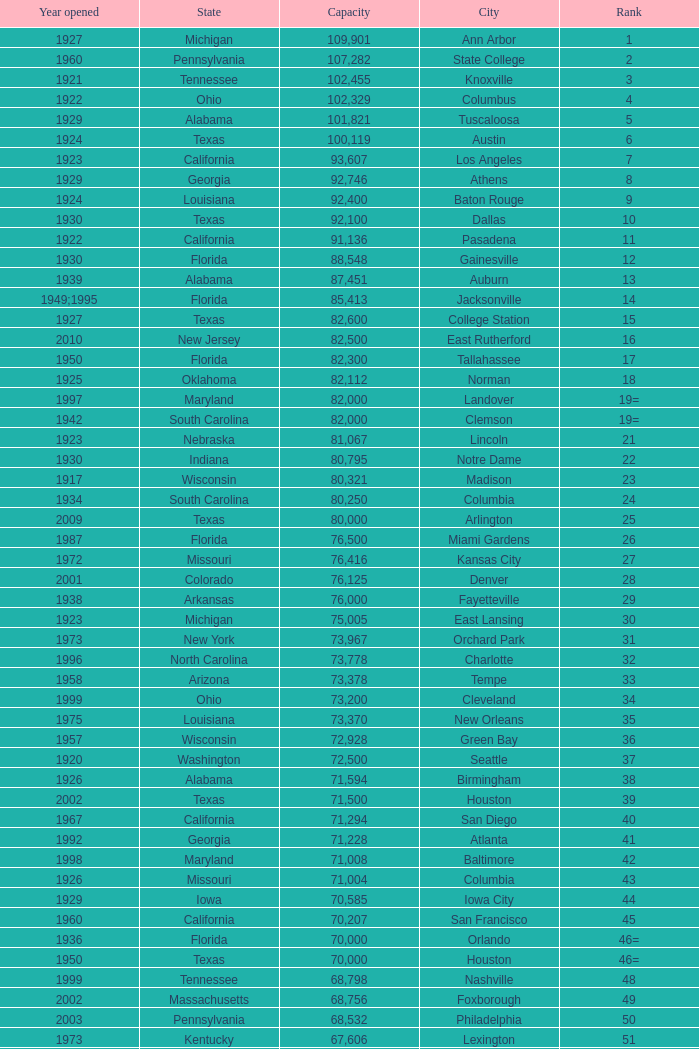What is the lowest capacity for 1903? 30323.0. Give me the full table as a dictionary. {'header': ['Year opened', 'State', 'Capacity', 'City', 'Rank'], 'rows': [['1927', 'Michigan', '109,901', 'Ann Arbor', '1'], ['1960', 'Pennsylvania', '107,282', 'State College', '2'], ['1921', 'Tennessee', '102,455', 'Knoxville', '3'], ['1922', 'Ohio', '102,329', 'Columbus', '4'], ['1929', 'Alabama', '101,821', 'Tuscaloosa', '5'], ['1924', 'Texas', '100,119', 'Austin', '6'], ['1923', 'California', '93,607', 'Los Angeles', '7'], ['1929', 'Georgia', '92,746', 'Athens', '8'], ['1924', 'Louisiana', '92,400', 'Baton Rouge', '9'], ['1930', 'Texas', '92,100', 'Dallas', '10'], ['1922', 'California', '91,136', 'Pasadena', '11'], ['1930', 'Florida', '88,548', 'Gainesville', '12'], ['1939', 'Alabama', '87,451', 'Auburn', '13'], ['1949;1995', 'Florida', '85,413', 'Jacksonville', '14'], ['1927', 'Texas', '82,600', 'College Station', '15'], ['2010', 'New Jersey', '82,500', 'East Rutherford', '16'], ['1950', 'Florida', '82,300', 'Tallahassee', '17'], ['1925', 'Oklahoma', '82,112', 'Norman', '18'], ['1997', 'Maryland', '82,000', 'Landover', '19='], ['1942', 'South Carolina', '82,000', 'Clemson', '19='], ['1923', 'Nebraska', '81,067', 'Lincoln', '21'], ['1930', 'Indiana', '80,795', 'Notre Dame', '22'], ['1917', 'Wisconsin', '80,321', 'Madison', '23'], ['1934', 'South Carolina', '80,250', 'Columbia', '24'], ['2009', 'Texas', '80,000', 'Arlington', '25'], ['1987', 'Florida', '76,500', 'Miami Gardens', '26'], ['1972', 'Missouri', '76,416', 'Kansas City', '27'], ['2001', 'Colorado', '76,125', 'Denver', '28'], ['1938', 'Arkansas', '76,000', 'Fayetteville', '29'], ['1923', 'Michigan', '75,005', 'East Lansing', '30'], ['1973', 'New York', '73,967', 'Orchard Park', '31'], ['1996', 'North Carolina', '73,778', 'Charlotte', '32'], ['1958', 'Arizona', '73,378', 'Tempe', '33'], ['1999', 'Ohio', '73,200', 'Cleveland', '34'], ['1975', 'Louisiana', '73,370', 'New Orleans', '35'], ['1957', 'Wisconsin', '72,928', 'Green Bay', '36'], ['1920', 'Washington', '72,500', 'Seattle', '37'], ['1926', 'Alabama', '71,594', 'Birmingham', '38'], ['2002', 'Texas', '71,500', 'Houston', '39'], ['1967', 'California', '71,294', 'San Diego', '40'], ['1992', 'Georgia', '71,228', 'Atlanta', '41'], ['1998', 'Maryland', '71,008', 'Baltimore', '42'], ['1926', 'Missouri', '71,004', 'Columbia', '43'], ['1929', 'Iowa', '70,585', 'Iowa City', '44'], ['1960', 'California', '70,207', 'San Francisco', '45'], ['1936', 'Florida', '70,000', 'Orlando', '46='], ['1950', 'Texas', '70,000', 'Houston', '46='], ['1999', 'Tennessee', '68,798', 'Nashville', '48'], ['2002', 'Massachusetts', '68,756', 'Foxborough', '49'], ['2003', 'Pennsylvania', '68,532', 'Philadelphia', '50'], ['1973', 'Kentucky', '67,606', 'Lexington', '51'], ['2002', 'Washington', '67,000', 'Seattle', '52'], ['1995', 'Missouri', '66,965', 'St. Louis', '53'], ['1965', 'Virginia', '66,233', 'Blacksburg', '54'], ['1998', 'Florida', '65,857', 'Tampa', '55'], ['2000', 'Ohio', '65,790', 'Cincinnati', '56'], ['2001', 'Pennsylvania', '65,050', 'Pittsburgh', '57'], ['1993', 'Texas', '65,000', 'San Antonio', '58='], ['2002', 'Michigan', '65,000', 'Detroit', '58='], ['1914', 'Connecticut', '64,269', 'New Haven', '60'], ['1982', 'Minnesota', '64,111', 'Minneapolis', '61'], ['1964', 'Utah', '64,045', 'Provo', '62'], ['2006', 'Arizona', '63,400', 'Glendale', '63'], ['1966', 'California', '63,026', 'Oakland', '64'], ['2008', 'Indiana', '63,000', 'Indianapolis', '65'], ['1926', 'North Carolina', '63.000', 'Chapel Hill', '65'], ['1923', 'Illinois', '62,872', 'Champaign', '66'], ['1923', 'California', '62,717', 'Berkeley', '67'], ['1924;2003', 'Illinois', '61,500', 'Chicago', '68'], ['1924', 'Indiana', '62,500', 'West Lafayette', '69'], ['1965', 'Tennessee', '62,380', 'Memphis', '70'], ['1931', 'Virginia', '61,500', 'Charlottesville', '71'], ['1947', 'Texas', '61,000', 'Lubbock', '72'], ['1915', 'Mississippi', '60,580', 'Oxford', '73'], ['1980', 'West Virginia', '60,540', 'Morgantown', '74'], ['1941', 'Mississippi', '60,492', 'Jackson', '75'], ['1920', 'Oklahoma', '60,000', 'Stillwater', '76'], ['1928', 'Arizona', '57,803', 'Tucson', '78'], ['1966', 'North Carolina', '57,583', 'Raleigh', '79'], ['1961', 'District of Columbia', '56,692', 'Washington, D.C.', '80'], ['1962', 'California', '56,000', 'Los Angeles', '81='], ['1998', 'Kentucky', '56,000', 'Louisville', '81='], ['1914', 'Mississippi', '55,082', 'Starkville', '83'], ['1913', 'Georgia', '55,000', 'Atlanta', '84='], ['1975', 'Iowa', '55,000', 'Ames', '84='], ['1967', 'Oregon', '53,800', 'Eugene', '86'], ['1924', 'Colorado', '53,750', 'Boulder', '87'], ['1948', 'Arkansas', '53,727', 'Little Rock', '88'], ['1960', 'Indiana', '53,500', 'Bloomington', '89'], ['1895', 'Pennsylvania', '52,593', 'Philadelphia', '90'], ['1962', 'Colorado', '52,480', 'Colorado Springs', '91'], ['1994', 'New Jersey', '52,454', 'Piscataway', '92'], ['1968', 'Kansas', '52,200', 'Manhattan', '93'], ['1950', 'Maryland', '51,500', 'College Park', '94='], ['1963', 'Texas', '51,500', 'El Paso', '94='], ['1925', 'Louisiana', '50,832', 'Shreveport', '96'], ['2009', 'Minnesota', '50,805', 'Minneapolis', '97'], ['1995', 'Colorado', '50,445', 'Denver', '98'], ['2009', 'New York', '50,291', 'Bronx', '99'], ['1996', 'Georgia', '50,096', 'Atlanta', '100'], ['1921', 'Kansas', '50,071', 'Lawrence', '101'], ['1975', 'Hawai ʻ i', '50,000', 'Honolulu', '102='], ['1963', 'North Carolina', '50,000', 'Greenville', '102='], ['1950', 'Texas', '50,000', 'Waco', '102='], ['1921;2006', 'California', '50,000', 'Stanford', '102='], ['1980', 'New York', '49,262', 'Syracuse', '106'], ['1994', 'Texas', '49,115', 'Arlington', '107'], ['1998', 'Arizona', '49,033', 'Phoenix', '108'], ['1992', 'Maryland', '48,876', 'Baltimore', '109'], ['1996', 'Illinois', '47,130', 'Evanston', '110'], ['1999', 'Washington', '47,116', 'Seattle', '111'], ['2006', 'Missouri', '46,861', 'St. Louis', '112'], ['1953', 'Oregon', '45,674', 'Corvallis', '113'], ['1998', 'Utah', '45,634', 'Salt Lake City', '114'], ['2007', 'Florida', '45,301', 'Orlando', '115'], ['1966', 'California', '45,050', 'Anaheim', '116'], ['1957', 'Massachusetts', '44,500', 'Chestnut Hill', '117'], ['1930', 'Texas', '44,008', 'Fort Worth', '118'], ['2004', 'Pennsylvania', '43,647', 'Philadelphia', '119'], ['1994', 'Ohio', '43,545', 'Cleveland', '120'], ['2004', 'California', '42,445', 'San Diego', '121'], ['2003', 'Ohio', '42,059', 'Cincinnati', '122'], ['2001', 'Wisconsin', '41,900', 'Milwaukee', '123'], ['2008', 'District of Columbia', '41,888', 'Washington, D.C.', '124'], ['2009', 'New York', '41,800', 'Flushing, New York', '125'], ['2000', 'Michigan', '41,782', 'Detroit', '126'], ['2000', 'California', '41,503', 'San Francisco', '127'], ['1914', 'Illinois', '41,160', 'Chicago', '128'], ['1980', 'California', '41,031', 'Fresno', '129'], ['2000', 'Texas', '40,950', 'Houston', '130'], ['1948', 'Alabama', '40,646', 'Mobile', '131'], ['1991', 'Illinois', '40,615', 'Chicago', '132'], ['1960', 'New Mexico', '40,094', 'Albuquerque', '133'], ['1959', 'Pennsylvania', '40,000', 'South Williamsport', '134='], ['2003', 'Connecticut', '40,000', 'East Hartford', '134='], ['1924', 'New York', '40,000', 'West Point', '134='], ['1922', 'Tennessee', '39,790', 'Nashville', '137'], ['2010', 'Minnesota', '39,504', 'Minneapolis', '138'], ['1973', 'Missouri', '39,000', 'Kansas City', '139'], ['2001', 'Pennsylvania', '38,496', 'Pittsburgh', '140'], ['1991', 'West Virginia', '38,019', 'Huntington', '141'], ['1912', 'Massachusetts', '37,402', 'Boston', '142'], ['1970', 'Idaho', '37,000', 'Boise', '143='], ['2012', 'Florida', '37,000', 'Miami', '143='], ['1990', 'Florida', '36,973', 'St. Petersburg', '145'], ['1971', 'Nevada', '36,800', 'Whitney', '146'], ['1932', 'Mississippi', '36,000', 'Hattiesburg', '147'], ['1972', 'Washington', '35,117', 'Pullman', '148'], ['1924', 'Ohio', '35,097', 'Cincinnati', '149'], ['1968', 'Colorado', '34,400', 'Fort Collins', '150'], ['1959', 'Maryland', '34,000', 'Annapolis', '151'], ['1929', 'North Carolina', '33,941', 'Durham', '152'], ['1950', 'Wyoming', '32,580', 'Laramie', '153'], ['2000', 'Texas', '32,000', 'University Park', '154='], ['1942', 'Texas', '32,000', 'Houston', '154='], ['1968', 'North Carolina', '31,500', 'Winston-Salem', '156'], ['1971', 'Louisiana', '31,000', 'Lafayette', '157='], ['1940', 'Ohio', '31,000', 'Akron', '157='], ['1965', 'Illinois', '31,000', 'DeKalb', '157='], ['1974', 'Arkansas', '30,964', 'Jonesboro', '160'], ['2011', 'Texas', '30,850', 'Denton', '161'], ['1960', 'Louisiana', '30,600', 'Ruston', '162'], ['1933', 'California', '30,456', 'San Jose', '163'], ['1978', 'Louisiana', '30,427', 'Monroe', '164'], ['1978', 'New Mexico', '30,343', 'Las Cruces', '165'], ['1903', 'Massachusetts', '30,323', 'Allston', '166'], ['1972', 'Michigan', '30,295', 'Mount Pleasant', '167'], ['1969', 'Michigan', '30,200', 'Ypsilanti', '168='], ['1939', 'Michigan', '30,200', 'Kalamazoo', '168='], ['2011', 'Florida', '30,000', 'Boca Raton', '168='], ['1981', 'Texas', '30,000', 'San Marcos', '168='], ['1930', 'Oklahoma', '30,000', 'Tulsa', '168='], ['2009', 'Ohio', '30,000', 'Akron', '168='], ['1950', 'Alabama', '30,000', 'Troy', '168='], ['1997', 'Virginia', '30,000', 'Norfolk', '168='], ['1966', 'Nevada', '29,993', 'Reno', '176'], ['1993', 'New York', '29,013', 'Amherst', '177'], ['1928', 'Louisiana', '29,000', 'Baton Rouge', '178'], ['1950', 'Washington', '28,646', 'Spokane', '179'], ['1998', 'New Jersey', '27,800', 'Princeton', '180'], ['2003', 'California', '27,000', 'Carson', '181'], ['1937', 'Ohio', '26,248', 'Toledo', '182'], ['1983', 'Louisiana', '25,600', 'Grambling', '183'], ['1915', 'New York', '25,597', 'Ithaca', '184'], ['1957', 'Florida', '25,500', 'Tallahassee', '185'], ['1967', 'Indiana', '25,400', 'Muncie', '186'], ['1986', 'Montana', '25,200', 'Missoula', '187'], ['2010', 'New Jersey', '25,189', 'Harrison', '188'], ['1969', 'Ohio', '25,000', 'Kent', '189'], ['1975', 'Virginia', '24,877', 'Harrisonburg', '190'], ['1922', 'Alabama', '24,600', 'Montgomery', '191'], ['1983', 'Ohio', '24,286', 'Oxford', '192'], ['2011', 'Nebraska', '24,000', 'Omaha', '193='], ['1929', 'Ohio', '24,000', 'Athens', '193='], ['1966', 'Ohio', '23,724', 'Bowling Green', '194'], ['1924', 'Massachusetts', '23,500', 'Worcester', '195'], ['1992', 'Mississippi', '22,500', 'Lorman', '196'], ['2012', 'Texas', '22,000', 'Houston', '197='], ['1952', 'Delaware', '22,000', 'Newark', '197='], ['1968', 'Kentucky', '22,000', 'Bowling Green', '197='], ['1955', 'South Carolina', '22,000', 'Orangeburg', '197='], ['1962', 'North Carolina', '21,650', 'Boone', '201'], ['1981', 'North Carolina', '21,500', 'Greensboro', '202'], ['1969', 'California', '21,650', 'Sacramento', '203'], ['1946', 'South Carolina', '21,000', 'Charleston', '204='], ['1996', 'Alabama', '21,000', 'Huntsville', '204='], ['1994', 'Illinois', '21,000', 'Chicago', '204='], ['1997', 'Tennessee', '20,668', 'Chattanooga', '207'], ['1982', 'Ohio', '20,630', 'Youngstown', '208'], ['2005', 'Texas', '20,500', 'Frisco', '209'], ['1999', 'Ohio', '20,455', 'Columbus', '210'], ['1959', 'Florida', '20,450', 'Fort Lauderdale', '211'], ['1926', 'Oregon', '20,438', 'Portland', '212'], ['1928', 'California', '20,311', 'Sacramento, California', '213'], ['1979', 'Michigan', '20,066', 'Detroit, Michigan', '214'], ['2008', 'Utah', '20,008', 'Sandy', '215'], ['1925', 'Rhode Island', '20,000', 'Providence', '216='], ['1995', 'Florida', '20,000', 'Miami', '216='], ['1969', 'Kentucky', '20,000', 'Richmond', '216='], ['1977', 'Texas', '20,000', 'Mesquite', '216='], ['1959', 'Texas', '20,000', 'Canyon', '216='], ['2006', 'Illinois', '20,000', 'Bridgeview', '216=']]} 